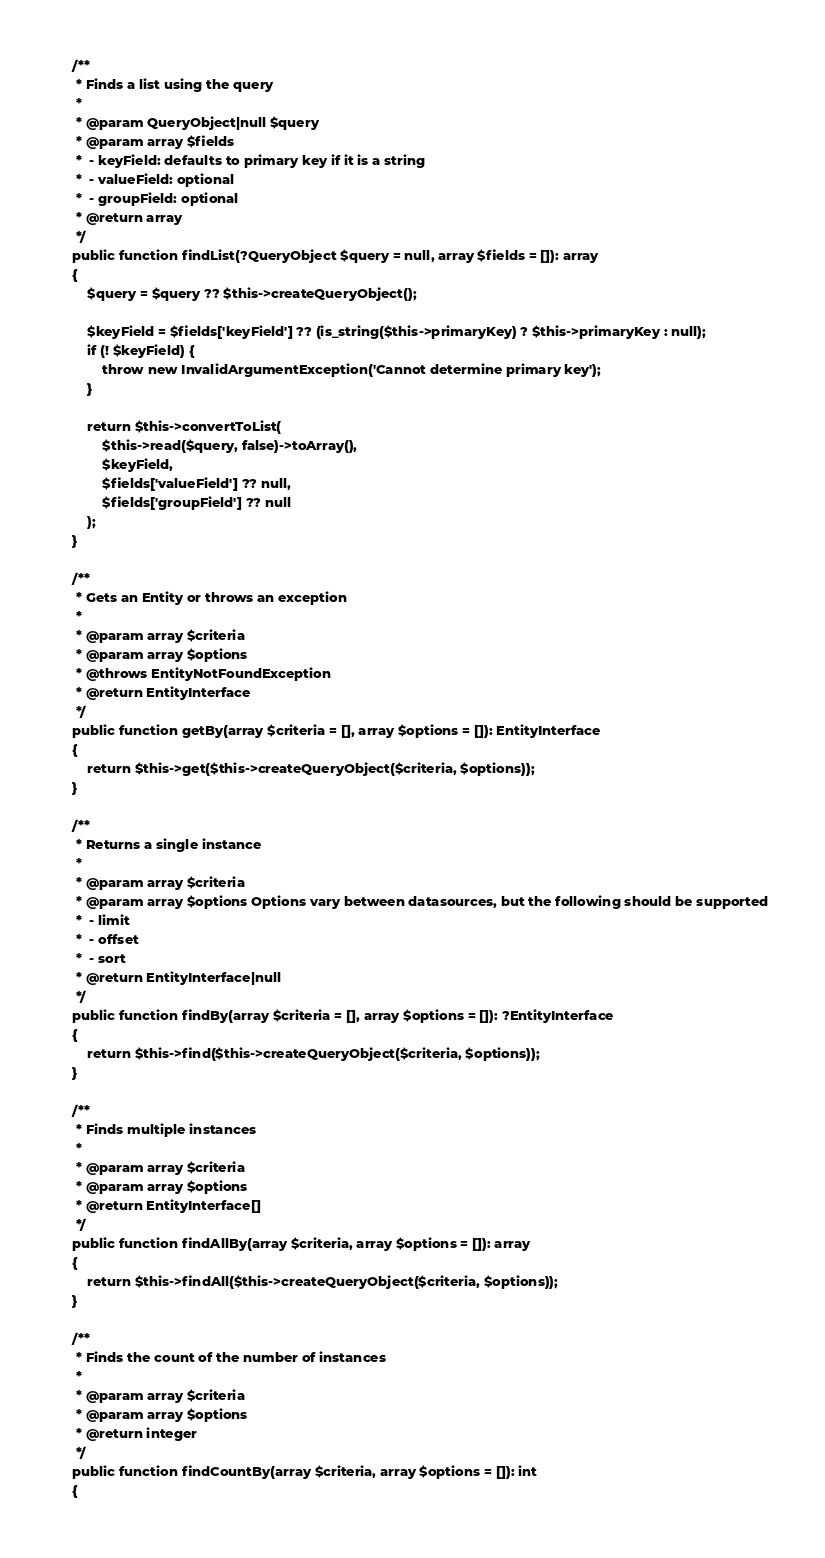<code> <loc_0><loc_0><loc_500><loc_500><_PHP_>
    /**
     * Finds a list using the query
     *
     * @param QueryObject|null $query
     * @param array $fields
     *  - keyField: defaults to primary key if it is a string
     *  - valueField: optional
     *  - groupField: optional
     * @return array
     */
    public function findList(?QueryObject $query = null, array $fields = []): array
    {
        $query = $query ?? $this->createQueryObject();

        $keyField = $fields['keyField'] ?? (is_string($this->primaryKey) ? $this->primaryKey : null);
        if (! $keyField) {
            throw new InvalidArgumentException('Cannot determine primary key');
        }

        return $this->convertToList(
            $this->read($query, false)->toArray(),
            $keyField,
            $fields['valueField'] ?? null,
            $fields['groupField'] ?? null
        );
    }

    /**
     * Gets an Entity or throws an exception
     *
     * @param array $criteria
     * @param array $options
     * @throws EntityNotFoundException
     * @return EntityInterface
     */
    public function getBy(array $criteria = [], array $options = []): EntityInterface
    {
        return $this->get($this->createQueryObject($criteria, $options));
    }

    /**
     * Returns a single instance
     *
     * @param array $criteria
     * @param array $options Options vary between datasources, but the following should be supported
     *  - limit
     *  - offset
     *  - sort
     * @return EntityInterface|null
     */
    public function findBy(array $criteria = [], array $options = []): ?EntityInterface
    {
        return $this->find($this->createQueryObject($criteria, $options));
    }

    /**
     * Finds multiple instances
     *
     * @param array $criteria
     * @param array $options
     * @return EntityInterface[]
     */
    public function findAllBy(array $criteria, array $options = []): array
    {
        return $this->findAll($this->createQueryObject($criteria, $options));
    }

    /**
     * Finds the count of the number of instances
     *
     * @param array $criteria
     * @param array $options
     * @return integer
     */
    public function findCountBy(array $criteria, array $options = []): int
    {</code> 